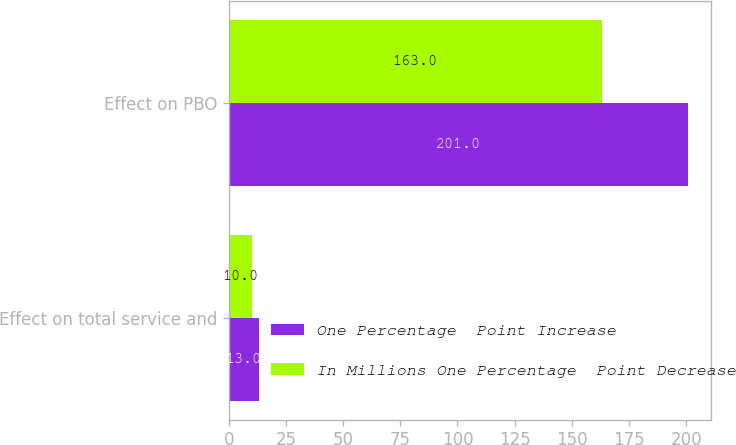<chart> <loc_0><loc_0><loc_500><loc_500><stacked_bar_chart><ecel><fcel>Effect on total service and<fcel>Effect on PBO<nl><fcel>One Percentage  Point Increase<fcel>13<fcel>201<nl><fcel>In Millions One Percentage  Point Decrease<fcel>10<fcel>163<nl></chart> 